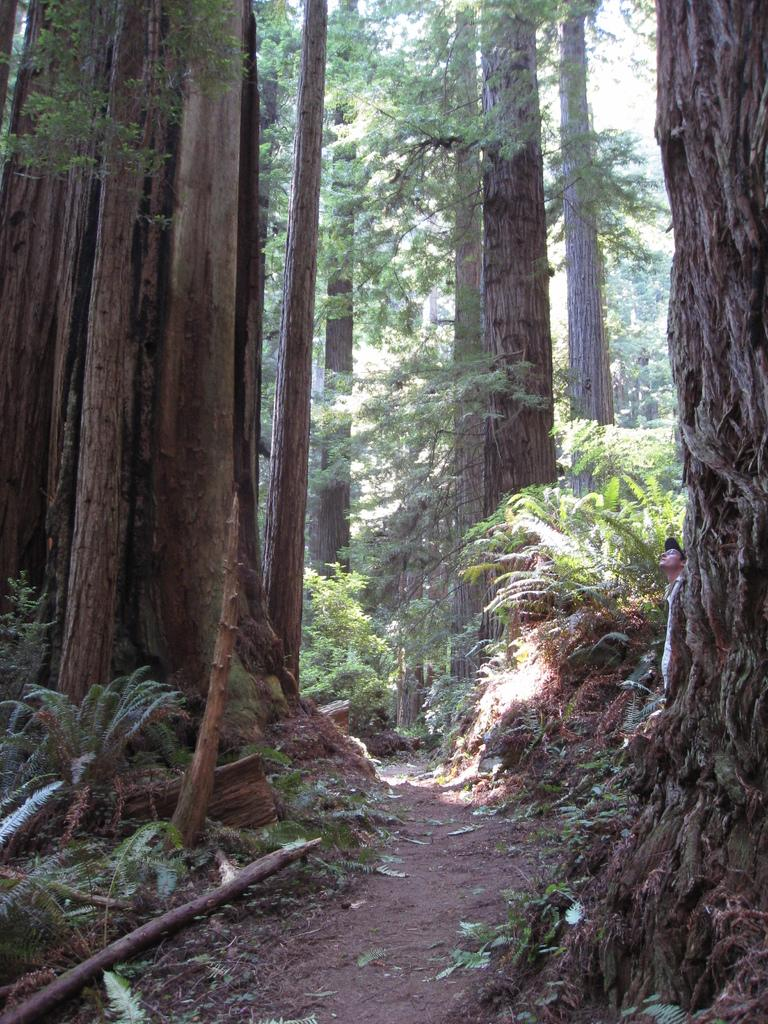What is the main feature of the landscape in the image? There is a path in the image. What objects can be seen along the path? There are wooden logs in the image. What type of vegetation is present in the image? There are trees in the image. Who is present in the image? A person wearing a black hat is standing in the image. What is on the ground in the image? There are leaves on the ground in the image. What can be seen in the distance in the image? The sky is visible in the background of the image. What type of cat can be seen playing with a sheet in the image? There is no cat or sheet present in the image. What is the person in the image doing with the pet? There is no pet present in the image, and the person is simply standing there wearing a black hat. 